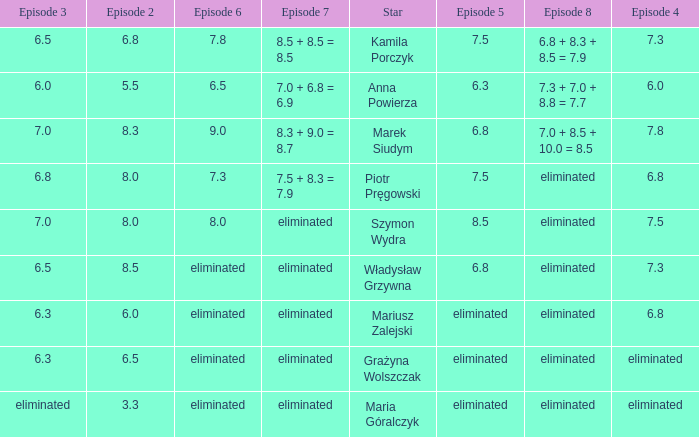Which episode 4 has a Star of anna powierza? 6.0. 